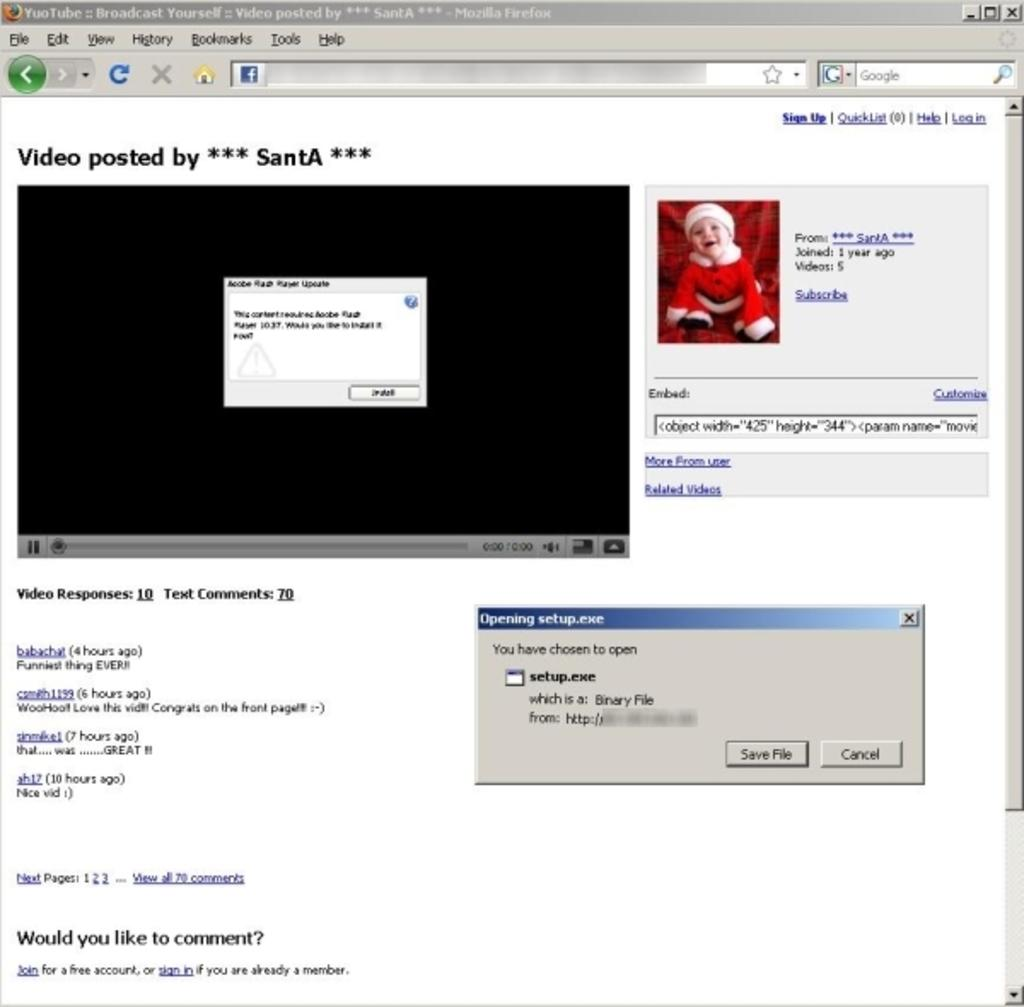<image>
Offer a succinct explanation of the picture presented. a webpage showing a video posted by ***SantA*** 